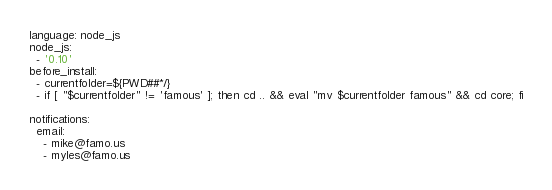Convert code to text. <code><loc_0><loc_0><loc_500><loc_500><_YAML_>language: node_js
node_js:
  - '0.10'
before_install:
  - currentfolder=${PWD##*/}
  - if [ "$currentfolder" != 'famous' ]; then cd .. && eval "mv $currentfolder famous" && cd core; fi

notifications:
  email:
    - mike@famo.us
    - myles@famo.us
</code> 